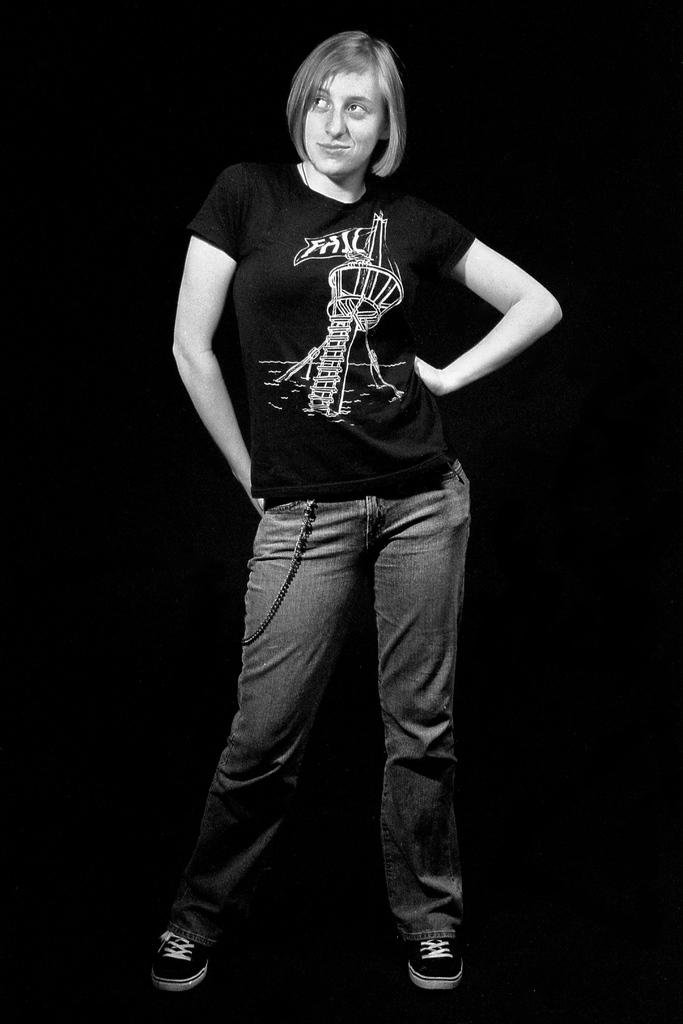What is the main subject of the image? There is a person in the image. What is the person wearing on their upper body? The person is wearing a black T-shirt. What type of pants is the person wearing? The person is wearing jeans. What type of footwear is the person wearing? The person is wearing shoes. What is the person's posture in the image? The person is standing. What type of waste can be seen in the person's hand in the image? There is no waste visible in the person's hand in the image. Is there a note attached to the person's clothing in the image? There is no note attached to the person's clothing in the image. What type of music is being played in the background of the image? There is no information about music being played in the image. 